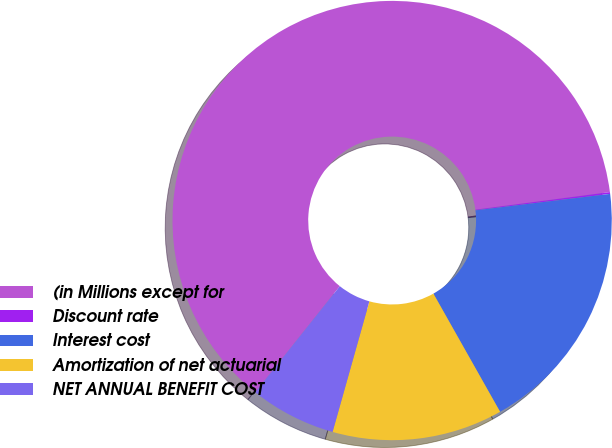Convert chart. <chart><loc_0><loc_0><loc_500><loc_500><pie_chart><fcel>(in Millions except for<fcel>Discount rate<fcel>Interest cost<fcel>Amortization of net actuarial<fcel>NET ANNUAL BENEFIT COST<nl><fcel>62.23%<fcel>0.13%<fcel>18.76%<fcel>12.55%<fcel>6.34%<nl></chart> 